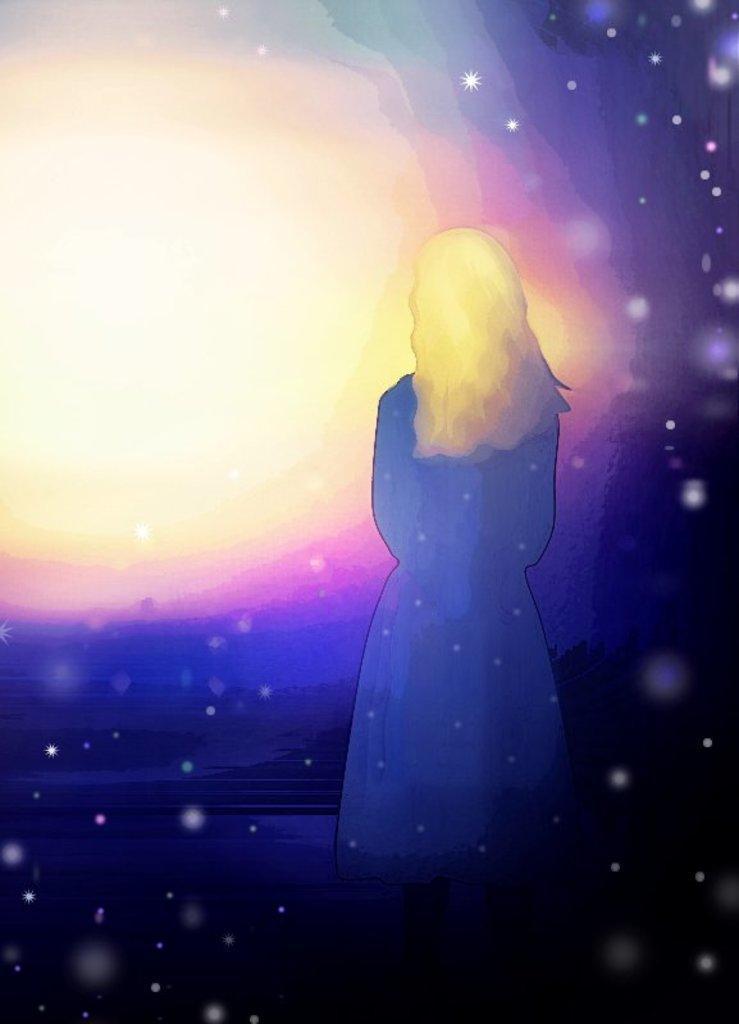Please provide a concise description of this image. It is a graphical picture. In the image in the center we can see one person. In the background we can see the lights. 